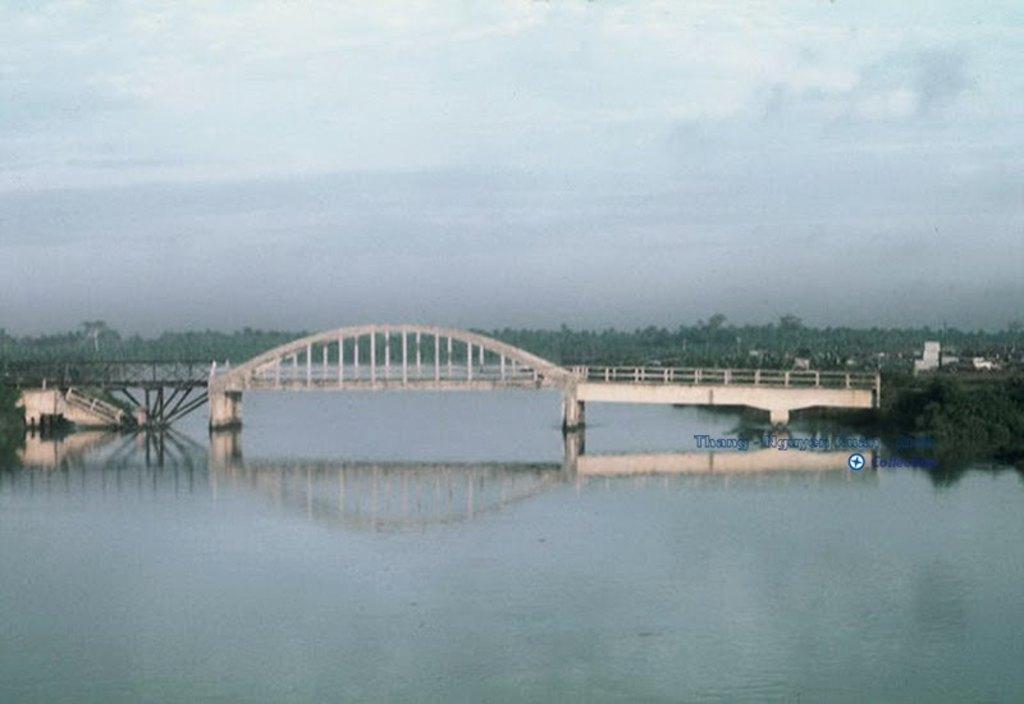What type of structure is present in the image? There is a concrete bridge in the image. What is the bridge positioned over? The bridge is over a river. What type of vegetation can be seen in the image? There are trees visible in the image. What type of building is present in the image? There is a house in the image. What is visible in the background of the image? The sky is visible in the image. How many books are on the windowsill of the house in the image? There are no books or windowsills visible in the image. Is there a spy observing the bridge from the trees in the image? There is no indication of a spy or any person in the trees in the image. 